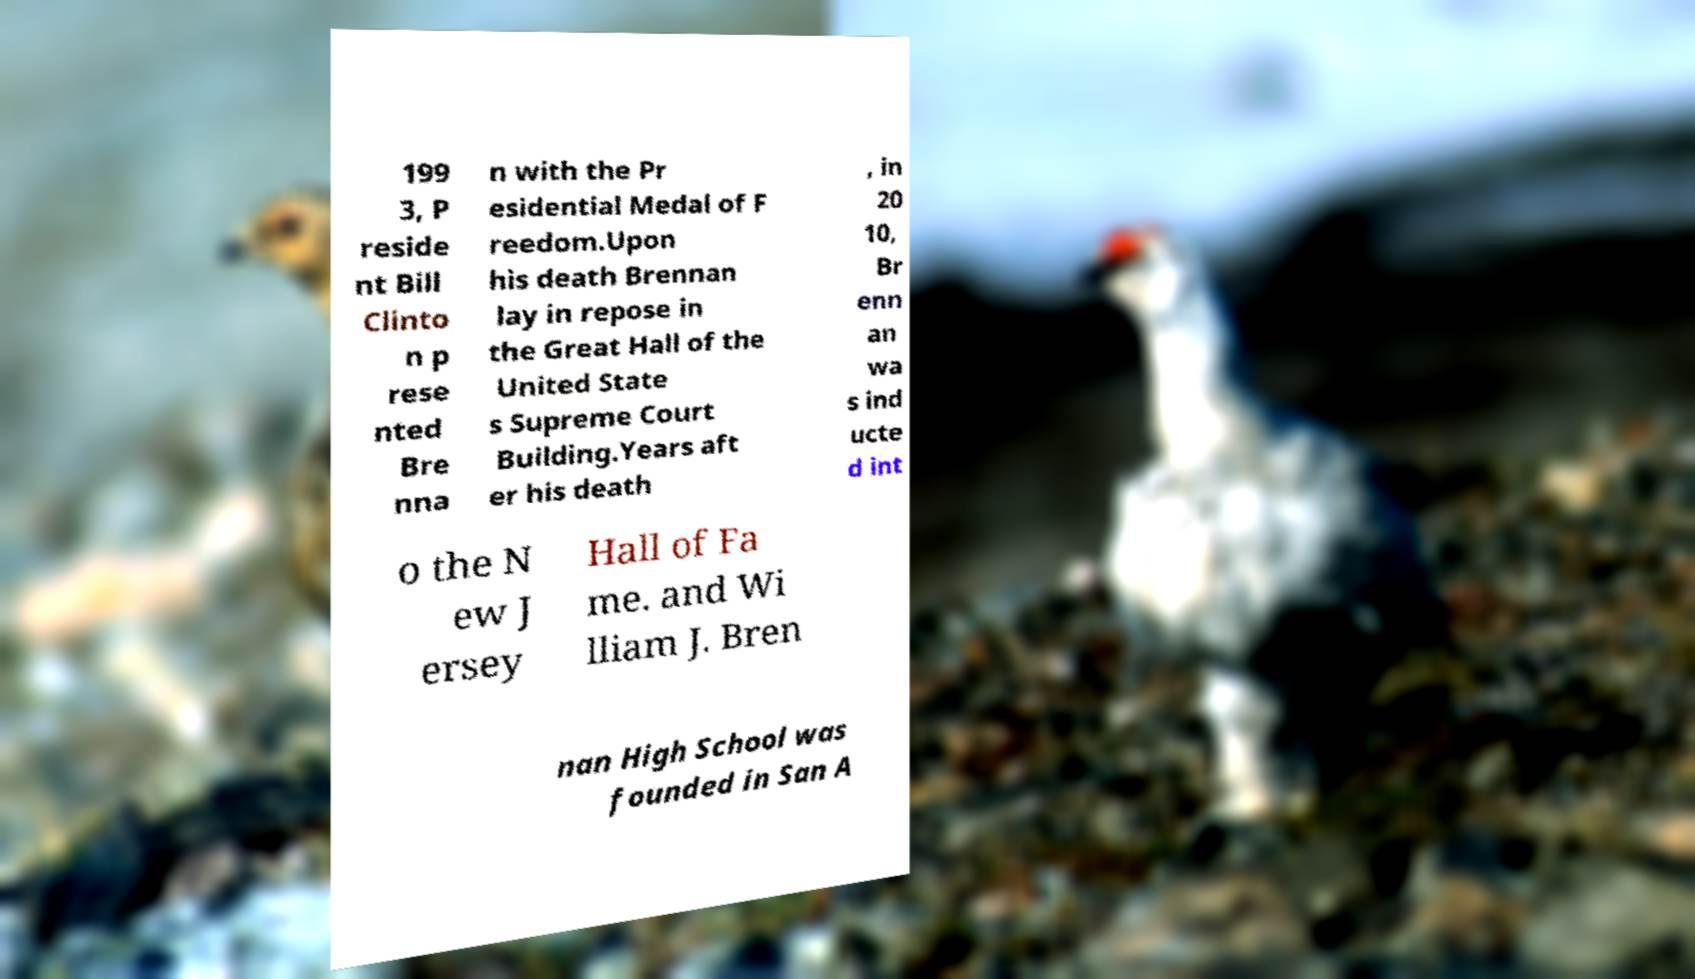Please read and relay the text visible in this image. What does it say? 199 3, P reside nt Bill Clinto n p rese nted Bre nna n with the Pr esidential Medal of F reedom.Upon his death Brennan lay in repose in the Great Hall of the United State s Supreme Court Building.Years aft er his death , in 20 10, Br enn an wa s ind ucte d int o the N ew J ersey Hall of Fa me. and Wi lliam J. Bren nan High School was founded in San A 